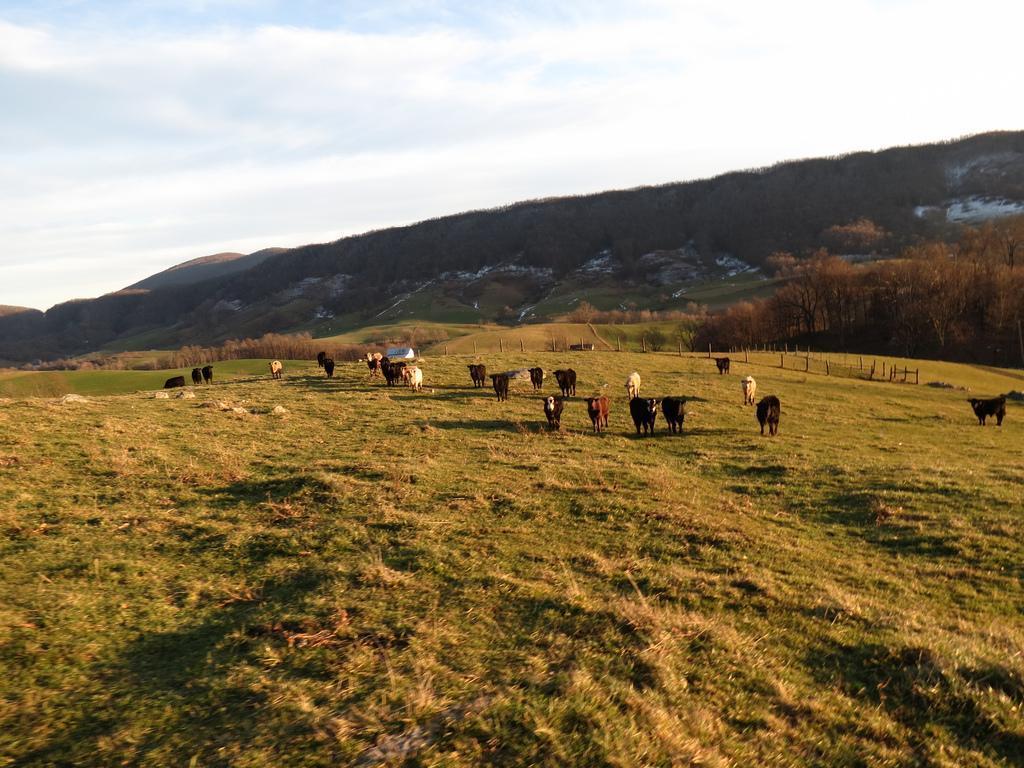How many mountains are in the photo?
Give a very brief answer. 1. How many dinosaurs are in the picture?
Give a very brief answer. 0. How many people are in the picture?
Give a very brief answer. 0. 